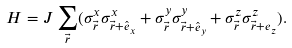<formula> <loc_0><loc_0><loc_500><loc_500>H = J \sum _ { \vec { r } } ( \sigma ^ { x } _ { \vec { r } } \sigma ^ { x } _ { \vec { r } + \hat { e } _ { x } } + \sigma ^ { y } _ { \vec { r } } \sigma ^ { y } _ { \vec { r } + \hat { e } _ { y } } + \sigma ^ { z } _ { \vec { r } } \sigma ^ { z } _ { \vec { r } + e _ { z } } ) .</formula> 